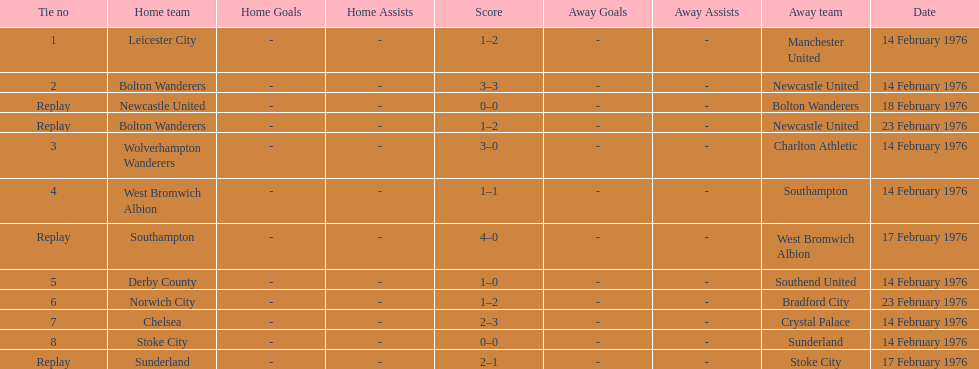Who was the home team in the game on the top of the table? Leicester City. 